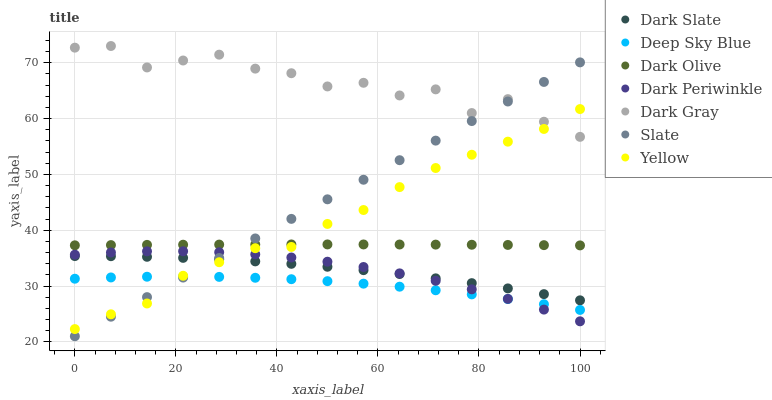Does Deep Sky Blue have the minimum area under the curve?
Answer yes or no. Yes. Does Dark Gray have the maximum area under the curve?
Answer yes or no. Yes. Does Dark Olive have the minimum area under the curve?
Answer yes or no. No. Does Dark Olive have the maximum area under the curve?
Answer yes or no. No. Is Slate the smoothest?
Answer yes or no. Yes. Is Dark Gray the roughest?
Answer yes or no. Yes. Is Dark Olive the smoothest?
Answer yes or no. No. Is Dark Olive the roughest?
Answer yes or no. No. Does Slate have the lowest value?
Answer yes or no. Yes. Does Dark Olive have the lowest value?
Answer yes or no. No. Does Dark Gray have the highest value?
Answer yes or no. Yes. Does Dark Olive have the highest value?
Answer yes or no. No. Is Dark Periwinkle less than Dark Gray?
Answer yes or no. Yes. Is Dark Gray greater than Deep Sky Blue?
Answer yes or no. Yes. Does Deep Sky Blue intersect Slate?
Answer yes or no. Yes. Is Deep Sky Blue less than Slate?
Answer yes or no. No. Is Deep Sky Blue greater than Slate?
Answer yes or no. No. Does Dark Periwinkle intersect Dark Gray?
Answer yes or no. No. 